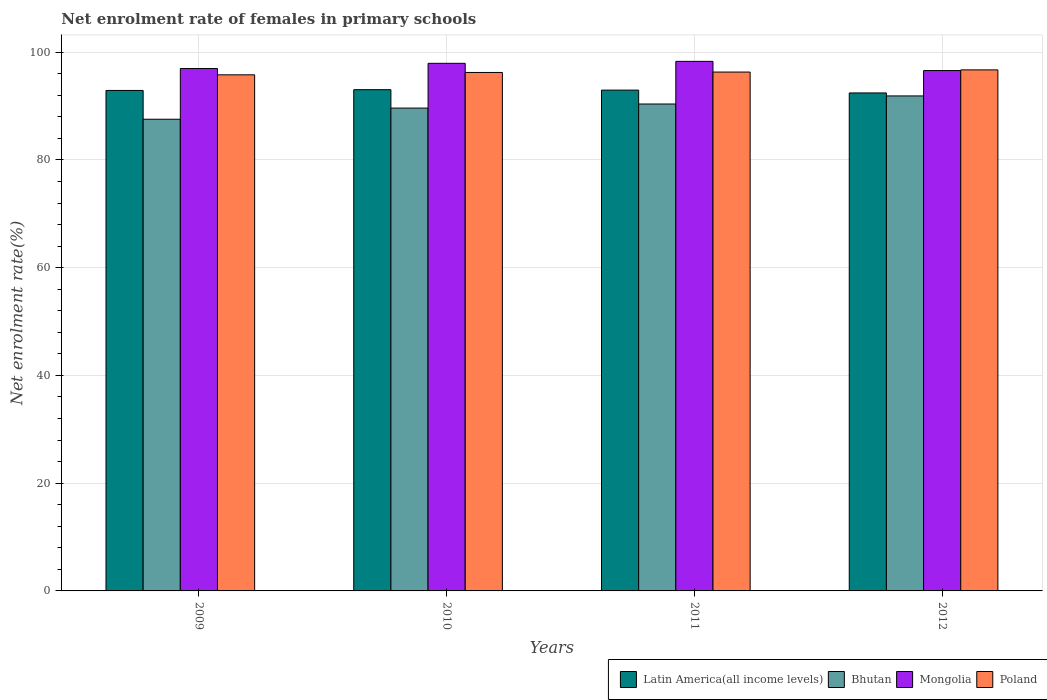How many different coloured bars are there?
Your answer should be very brief. 4. How many groups of bars are there?
Your answer should be compact. 4. Are the number of bars per tick equal to the number of legend labels?
Make the answer very short. Yes. Are the number of bars on each tick of the X-axis equal?
Keep it short and to the point. Yes. How many bars are there on the 2nd tick from the left?
Your answer should be compact. 4. How many bars are there on the 1st tick from the right?
Provide a succinct answer. 4. What is the label of the 2nd group of bars from the left?
Give a very brief answer. 2010. What is the net enrolment rate of females in primary schools in Bhutan in 2012?
Keep it short and to the point. 91.89. Across all years, what is the maximum net enrolment rate of females in primary schools in Mongolia?
Keep it short and to the point. 98.31. Across all years, what is the minimum net enrolment rate of females in primary schools in Bhutan?
Your answer should be very brief. 87.56. In which year was the net enrolment rate of females in primary schools in Latin America(all income levels) minimum?
Your response must be concise. 2012. What is the total net enrolment rate of females in primary schools in Poland in the graph?
Keep it short and to the point. 385.11. What is the difference between the net enrolment rate of females in primary schools in Poland in 2009 and that in 2012?
Make the answer very short. -0.92. What is the difference between the net enrolment rate of females in primary schools in Poland in 2011 and the net enrolment rate of females in primary schools in Mongolia in 2010?
Offer a terse response. -1.62. What is the average net enrolment rate of females in primary schools in Latin America(all income levels) per year?
Your answer should be compact. 92.84. In the year 2010, what is the difference between the net enrolment rate of females in primary schools in Poland and net enrolment rate of females in primary schools in Bhutan?
Make the answer very short. 6.61. In how many years, is the net enrolment rate of females in primary schools in Mongolia greater than 52 %?
Offer a terse response. 4. What is the ratio of the net enrolment rate of females in primary schools in Mongolia in 2009 to that in 2012?
Your response must be concise. 1. Is the net enrolment rate of females in primary schools in Bhutan in 2009 less than that in 2011?
Give a very brief answer. Yes. What is the difference between the highest and the second highest net enrolment rate of females in primary schools in Bhutan?
Make the answer very short. 1.5. What is the difference between the highest and the lowest net enrolment rate of females in primary schools in Bhutan?
Your answer should be very brief. 4.33. In how many years, is the net enrolment rate of females in primary schools in Mongolia greater than the average net enrolment rate of females in primary schools in Mongolia taken over all years?
Your response must be concise. 2. What does the 3rd bar from the left in 2011 represents?
Give a very brief answer. Mongolia. What does the 4th bar from the right in 2009 represents?
Keep it short and to the point. Latin America(all income levels). How many years are there in the graph?
Make the answer very short. 4. What is the difference between two consecutive major ticks on the Y-axis?
Offer a very short reply. 20. Are the values on the major ticks of Y-axis written in scientific E-notation?
Provide a succinct answer. No. Does the graph contain any zero values?
Offer a terse response. No. How many legend labels are there?
Give a very brief answer. 4. How are the legend labels stacked?
Provide a short and direct response. Horizontal. What is the title of the graph?
Your response must be concise. Net enrolment rate of females in primary schools. What is the label or title of the Y-axis?
Your answer should be very brief. Net enrolment rate(%). What is the Net enrolment rate(%) in Latin America(all income levels) in 2009?
Provide a short and direct response. 92.91. What is the Net enrolment rate(%) in Bhutan in 2009?
Give a very brief answer. 87.56. What is the Net enrolment rate(%) of Mongolia in 2009?
Provide a succinct answer. 96.97. What is the Net enrolment rate(%) in Poland in 2009?
Your response must be concise. 95.81. What is the Net enrolment rate(%) in Latin America(all income levels) in 2010?
Your answer should be compact. 93.05. What is the Net enrolment rate(%) of Bhutan in 2010?
Provide a short and direct response. 89.63. What is the Net enrolment rate(%) of Mongolia in 2010?
Your answer should be very brief. 97.94. What is the Net enrolment rate(%) of Poland in 2010?
Provide a succinct answer. 96.25. What is the Net enrolment rate(%) in Latin America(all income levels) in 2011?
Offer a very short reply. 92.97. What is the Net enrolment rate(%) of Bhutan in 2011?
Ensure brevity in your answer.  90.39. What is the Net enrolment rate(%) of Mongolia in 2011?
Offer a terse response. 98.31. What is the Net enrolment rate(%) of Poland in 2011?
Offer a terse response. 96.32. What is the Net enrolment rate(%) of Latin America(all income levels) in 2012?
Your response must be concise. 92.45. What is the Net enrolment rate(%) of Bhutan in 2012?
Provide a succinct answer. 91.89. What is the Net enrolment rate(%) of Mongolia in 2012?
Provide a succinct answer. 96.6. What is the Net enrolment rate(%) of Poland in 2012?
Offer a very short reply. 96.73. Across all years, what is the maximum Net enrolment rate(%) of Latin America(all income levels)?
Keep it short and to the point. 93.05. Across all years, what is the maximum Net enrolment rate(%) of Bhutan?
Ensure brevity in your answer.  91.89. Across all years, what is the maximum Net enrolment rate(%) of Mongolia?
Your response must be concise. 98.31. Across all years, what is the maximum Net enrolment rate(%) of Poland?
Your answer should be very brief. 96.73. Across all years, what is the minimum Net enrolment rate(%) of Latin America(all income levels)?
Provide a short and direct response. 92.45. Across all years, what is the minimum Net enrolment rate(%) in Bhutan?
Make the answer very short. 87.56. Across all years, what is the minimum Net enrolment rate(%) in Mongolia?
Your answer should be compact. 96.6. Across all years, what is the minimum Net enrolment rate(%) in Poland?
Offer a terse response. 95.81. What is the total Net enrolment rate(%) in Latin America(all income levels) in the graph?
Keep it short and to the point. 371.38. What is the total Net enrolment rate(%) in Bhutan in the graph?
Offer a very short reply. 359.48. What is the total Net enrolment rate(%) of Mongolia in the graph?
Your answer should be very brief. 389.83. What is the total Net enrolment rate(%) of Poland in the graph?
Make the answer very short. 385.11. What is the difference between the Net enrolment rate(%) of Latin America(all income levels) in 2009 and that in 2010?
Make the answer very short. -0.14. What is the difference between the Net enrolment rate(%) of Bhutan in 2009 and that in 2010?
Ensure brevity in your answer.  -2.07. What is the difference between the Net enrolment rate(%) in Mongolia in 2009 and that in 2010?
Provide a succinct answer. -0.97. What is the difference between the Net enrolment rate(%) in Poland in 2009 and that in 2010?
Keep it short and to the point. -0.44. What is the difference between the Net enrolment rate(%) in Latin America(all income levels) in 2009 and that in 2011?
Your answer should be very brief. -0.06. What is the difference between the Net enrolment rate(%) of Bhutan in 2009 and that in 2011?
Give a very brief answer. -2.83. What is the difference between the Net enrolment rate(%) in Mongolia in 2009 and that in 2011?
Your response must be concise. -1.33. What is the difference between the Net enrolment rate(%) in Poland in 2009 and that in 2011?
Offer a terse response. -0.52. What is the difference between the Net enrolment rate(%) of Latin America(all income levels) in 2009 and that in 2012?
Provide a short and direct response. 0.46. What is the difference between the Net enrolment rate(%) of Bhutan in 2009 and that in 2012?
Ensure brevity in your answer.  -4.33. What is the difference between the Net enrolment rate(%) in Mongolia in 2009 and that in 2012?
Your answer should be compact. 0.37. What is the difference between the Net enrolment rate(%) of Poland in 2009 and that in 2012?
Provide a succinct answer. -0.92. What is the difference between the Net enrolment rate(%) in Latin America(all income levels) in 2010 and that in 2011?
Your answer should be very brief. 0.08. What is the difference between the Net enrolment rate(%) of Bhutan in 2010 and that in 2011?
Your answer should be very brief. -0.76. What is the difference between the Net enrolment rate(%) of Mongolia in 2010 and that in 2011?
Your answer should be compact. -0.37. What is the difference between the Net enrolment rate(%) in Poland in 2010 and that in 2011?
Make the answer very short. -0.08. What is the difference between the Net enrolment rate(%) in Latin America(all income levels) in 2010 and that in 2012?
Offer a very short reply. 0.61. What is the difference between the Net enrolment rate(%) in Bhutan in 2010 and that in 2012?
Ensure brevity in your answer.  -2.26. What is the difference between the Net enrolment rate(%) in Mongolia in 2010 and that in 2012?
Provide a succinct answer. 1.34. What is the difference between the Net enrolment rate(%) of Poland in 2010 and that in 2012?
Ensure brevity in your answer.  -0.48. What is the difference between the Net enrolment rate(%) in Latin America(all income levels) in 2011 and that in 2012?
Your answer should be compact. 0.52. What is the difference between the Net enrolment rate(%) in Bhutan in 2011 and that in 2012?
Make the answer very short. -1.5. What is the difference between the Net enrolment rate(%) in Mongolia in 2011 and that in 2012?
Ensure brevity in your answer.  1.71. What is the difference between the Net enrolment rate(%) in Poland in 2011 and that in 2012?
Your answer should be very brief. -0.4. What is the difference between the Net enrolment rate(%) in Latin America(all income levels) in 2009 and the Net enrolment rate(%) in Bhutan in 2010?
Provide a succinct answer. 3.28. What is the difference between the Net enrolment rate(%) in Latin America(all income levels) in 2009 and the Net enrolment rate(%) in Mongolia in 2010?
Give a very brief answer. -5.04. What is the difference between the Net enrolment rate(%) in Latin America(all income levels) in 2009 and the Net enrolment rate(%) in Poland in 2010?
Give a very brief answer. -3.34. What is the difference between the Net enrolment rate(%) of Bhutan in 2009 and the Net enrolment rate(%) of Mongolia in 2010?
Offer a very short reply. -10.38. What is the difference between the Net enrolment rate(%) of Bhutan in 2009 and the Net enrolment rate(%) of Poland in 2010?
Your answer should be very brief. -8.69. What is the difference between the Net enrolment rate(%) of Mongolia in 2009 and the Net enrolment rate(%) of Poland in 2010?
Your answer should be very brief. 0.73. What is the difference between the Net enrolment rate(%) in Latin America(all income levels) in 2009 and the Net enrolment rate(%) in Bhutan in 2011?
Offer a very short reply. 2.52. What is the difference between the Net enrolment rate(%) of Latin America(all income levels) in 2009 and the Net enrolment rate(%) of Mongolia in 2011?
Keep it short and to the point. -5.4. What is the difference between the Net enrolment rate(%) in Latin America(all income levels) in 2009 and the Net enrolment rate(%) in Poland in 2011?
Offer a very short reply. -3.42. What is the difference between the Net enrolment rate(%) of Bhutan in 2009 and the Net enrolment rate(%) of Mongolia in 2011?
Ensure brevity in your answer.  -10.75. What is the difference between the Net enrolment rate(%) in Bhutan in 2009 and the Net enrolment rate(%) in Poland in 2011?
Offer a very short reply. -8.76. What is the difference between the Net enrolment rate(%) of Mongolia in 2009 and the Net enrolment rate(%) of Poland in 2011?
Provide a short and direct response. 0.65. What is the difference between the Net enrolment rate(%) of Latin America(all income levels) in 2009 and the Net enrolment rate(%) of Bhutan in 2012?
Ensure brevity in your answer.  1.02. What is the difference between the Net enrolment rate(%) in Latin America(all income levels) in 2009 and the Net enrolment rate(%) in Mongolia in 2012?
Offer a terse response. -3.69. What is the difference between the Net enrolment rate(%) in Latin America(all income levels) in 2009 and the Net enrolment rate(%) in Poland in 2012?
Ensure brevity in your answer.  -3.82. What is the difference between the Net enrolment rate(%) in Bhutan in 2009 and the Net enrolment rate(%) in Mongolia in 2012?
Provide a succinct answer. -9.04. What is the difference between the Net enrolment rate(%) of Bhutan in 2009 and the Net enrolment rate(%) of Poland in 2012?
Your answer should be compact. -9.17. What is the difference between the Net enrolment rate(%) in Mongolia in 2009 and the Net enrolment rate(%) in Poland in 2012?
Make the answer very short. 0.25. What is the difference between the Net enrolment rate(%) in Latin America(all income levels) in 2010 and the Net enrolment rate(%) in Bhutan in 2011?
Ensure brevity in your answer.  2.66. What is the difference between the Net enrolment rate(%) in Latin America(all income levels) in 2010 and the Net enrolment rate(%) in Mongolia in 2011?
Ensure brevity in your answer.  -5.26. What is the difference between the Net enrolment rate(%) in Latin America(all income levels) in 2010 and the Net enrolment rate(%) in Poland in 2011?
Provide a short and direct response. -3.27. What is the difference between the Net enrolment rate(%) of Bhutan in 2010 and the Net enrolment rate(%) of Mongolia in 2011?
Keep it short and to the point. -8.68. What is the difference between the Net enrolment rate(%) of Bhutan in 2010 and the Net enrolment rate(%) of Poland in 2011?
Offer a terse response. -6.69. What is the difference between the Net enrolment rate(%) in Mongolia in 2010 and the Net enrolment rate(%) in Poland in 2011?
Keep it short and to the point. 1.62. What is the difference between the Net enrolment rate(%) in Latin America(all income levels) in 2010 and the Net enrolment rate(%) in Bhutan in 2012?
Ensure brevity in your answer.  1.16. What is the difference between the Net enrolment rate(%) of Latin America(all income levels) in 2010 and the Net enrolment rate(%) of Mongolia in 2012?
Provide a succinct answer. -3.55. What is the difference between the Net enrolment rate(%) of Latin America(all income levels) in 2010 and the Net enrolment rate(%) of Poland in 2012?
Keep it short and to the point. -3.68. What is the difference between the Net enrolment rate(%) in Bhutan in 2010 and the Net enrolment rate(%) in Mongolia in 2012?
Give a very brief answer. -6.97. What is the difference between the Net enrolment rate(%) of Bhutan in 2010 and the Net enrolment rate(%) of Poland in 2012?
Provide a short and direct response. -7.09. What is the difference between the Net enrolment rate(%) in Mongolia in 2010 and the Net enrolment rate(%) in Poland in 2012?
Ensure brevity in your answer.  1.22. What is the difference between the Net enrolment rate(%) in Latin America(all income levels) in 2011 and the Net enrolment rate(%) in Bhutan in 2012?
Offer a very short reply. 1.08. What is the difference between the Net enrolment rate(%) in Latin America(all income levels) in 2011 and the Net enrolment rate(%) in Mongolia in 2012?
Provide a short and direct response. -3.63. What is the difference between the Net enrolment rate(%) of Latin America(all income levels) in 2011 and the Net enrolment rate(%) of Poland in 2012?
Make the answer very short. -3.76. What is the difference between the Net enrolment rate(%) of Bhutan in 2011 and the Net enrolment rate(%) of Mongolia in 2012?
Your answer should be very brief. -6.21. What is the difference between the Net enrolment rate(%) of Bhutan in 2011 and the Net enrolment rate(%) of Poland in 2012?
Your answer should be compact. -6.34. What is the difference between the Net enrolment rate(%) in Mongolia in 2011 and the Net enrolment rate(%) in Poland in 2012?
Your answer should be compact. 1.58. What is the average Net enrolment rate(%) of Latin America(all income levels) per year?
Offer a terse response. 92.84. What is the average Net enrolment rate(%) of Bhutan per year?
Offer a terse response. 89.87. What is the average Net enrolment rate(%) in Mongolia per year?
Offer a terse response. 97.46. What is the average Net enrolment rate(%) in Poland per year?
Your answer should be very brief. 96.28. In the year 2009, what is the difference between the Net enrolment rate(%) in Latin America(all income levels) and Net enrolment rate(%) in Bhutan?
Give a very brief answer. 5.35. In the year 2009, what is the difference between the Net enrolment rate(%) in Latin America(all income levels) and Net enrolment rate(%) in Mongolia?
Offer a very short reply. -4.07. In the year 2009, what is the difference between the Net enrolment rate(%) in Latin America(all income levels) and Net enrolment rate(%) in Poland?
Ensure brevity in your answer.  -2.9. In the year 2009, what is the difference between the Net enrolment rate(%) of Bhutan and Net enrolment rate(%) of Mongolia?
Give a very brief answer. -9.41. In the year 2009, what is the difference between the Net enrolment rate(%) of Bhutan and Net enrolment rate(%) of Poland?
Ensure brevity in your answer.  -8.25. In the year 2009, what is the difference between the Net enrolment rate(%) in Mongolia and Net enrolment rate(%) in Poland?
Make the answer very short. 1.17. In the year 2010, what is the difference between the Net enrolment rate(%) in Latin America(all income levels) and Net enrolment rate(%) in Bhutan?
Make the answer very short. 3.42. In the year 2010, what is the difference between the Net enrolment rate(%) of Latin America(all income levels) and Net enrolment rate(%) of Mongolia?
Provide a succinct answer. -4.89. In the year 2010, what is the difference between the Net enrolment rate(%) of Latin America(all income levels) and Net enrolment rate(%) of Poland?
Your response must be concise. -3.2. In the year 2010, what is the difference between the Net enrolment rate(%) of Bhutan and Net enrolment rate(%) of Mongolia?
Your response must be concise. -8.31. In the year 2010, what is the difference between the Net enrolment rate(%) of Bhutan and Net enrolment rate(%) of Poland?
Offer a terse response. -6.61. In the year 2010, what is the difference between the Net enrolment rate(%) in Mongolia and Net enrolment rate(%) in Poland?
Keep it short and to the point. 1.7. In the year 2011, what is the difference between the Net enrolment rate(%) in Latin America(all income levels) and Net enrolment rate(%) in Bhutan?
Offer a very short reply. 2.58. In the year 2011, what is the difference between the Net enrolment rate(%) of Latin America(all income levels) and Net enrolment rate(%) of Mongolia?
Your response must be concise. -5.34. In the year 2011, what is the difference between the Net enrolment rate(%) of Latin America(all income levels) and Net enrolment rate(%) of Poland?
Your answer should be compact. -3.35. In the year 2011, what is the difference between the Net enrolment rate(%) in Bhutan and Net enrolment rate(%) in Mongolia?
Provide a succinct answer. -7.92. In the year 2011, what is the difference between the Net enrolment rate(%) in Bhutan and Net enrolment rate(%) in Poland?
Keep it short and to the point. -5.93. In the year 2011, what is the difference between the Net enrolment rate(%) of Mongolia and Net enrolment rate(%) of Poland?
Provide a short and direct response. 1.99. In the year 2012, what is the difference between the Net enrolment rate(%) in Latin America(all income levels) and Net enrolment rate(%) in Bhutan?
Your answer should be very brief. 0.56. In the year 2012, what is the difference between the Net enrolment rate(%) in Latin America(all income levels) and Net enrolment rate(%) in Mongolia?
Offer a very short reply. -4.16. In the year 2012, what is the difference between the Net enrolment rate(%) of Latin America(all income levels) and Net enrolment rate(%) of Poland?
Your answer should be very brief. -4.28. In the year 2012, what is the difference between the Net enrolment rate(%) in Bhutan and Net enrolment rate(%) in Mongolia?
Ensure brevity in your answer.  -4.71. In the year 2012, what is the difference between the Net enrolment rate(%) in Bhutan and Net enrolment rate(%) in Poland?
Your answer should be very brief. -4.84. In the year 2012, what is the difference between the Net enrolment rate(%) in Mongolia and Net enrolment rate(%) in Poland?
Offer a terse response. -0.13. What is the ratio of the Net enrolment rate(%) of Bhutan in 2009 to that in 2010?
Give a very brief answer. 0.98. What is the ratio of the Net enrolment rate(%) of Poland in 2009 to that in 2010?
Make the answer very short. 1. What is the ratio of the Net enrolment rate(%) in Bhutan in 2009 to that in 2011?
Ensure brevity in your answer.  0.97. What is the ratio of the Net enrolment rate(%) in Mongolia in 2009 to that in 2011?
Your answer should be very brief. 0.99. What is the ratio of the Net enrolment rate(%) in Bhutan in 2009 to that in 2012?
Your answer should be compact. 0.95. What is the ratio of the Net enrolment rate(%) of Latin America(all income levels) in 2010 to that in 2011?
Ensure brevity in your answer.  1. What is the ratio of the Net enrolment rate(%) in Mongolia in 2010 to that in 2011?
Your answer should be very brief. 1. What is the ratio of the Net enrolment rate(%) in Latin America(all income levels) in 2010 to that in 2012?
Ensure brevity in your answer.  1.01. What is the ratio of the Net enrolment rate(%) of Bhutan in 2010 to that in 2012?
Your answer should be compact. 0.98. What is the ratio of the Net enrolment rate(%) in Mongolia in 2010 to that in 2012?
Your answer should be compact. 1.01. What is the ratio of the Net enrolment rate(%) in Poland in 2010 to that in 2012?
Ensure brevity in your answer.  0.99. What is the ratio of the Net enrolment rate(%) of Latin America(all income levels) in 2011 to that in 2012?
Your answer should be compact. 1.01. What is the ratio of the Net enrolment rate(%) of Bhutan in 2011 to that in 2012?
Keep it short and to the point. 0.98. What is the ratio of the Net enrolment rate(%) in Mongolia in 2011 to that in 2012?
Your answer should be very brief. 1.02. What is the ratio of the Net enrolment rate(%) of Poland in 2011 to that in 2012?
Offer a terse response. 1. What is the difference between the highest and the second highest Net enrolment rate(%) of Latin America(all income levels)?
Provide a succinct answer. 0.08. What is the difference between the highest and the second highest Net enrolment rate(%) of Bhutan?
Provide a succinct answer. 1.5. What is the difference between the highest and the second highest Net enrolment rate(%) of Mongolia?
Ensure brevity in your answer.  0.37. What is the difference between the highest and the second highest Net enrolment rate(%) of Poland?
Offer a very short reply. 0.4. What is the difference between the highest and the lowest Net enrolment rate(%) in Latin America(all income levels)?
Your answer should be very brief. 0.61. What is the difference between the highest and the lowest Net enrolment rate(%) of Bhutan?
Keep it short and to the point. 4.33. What is the difference between the highest and the lowest Net enrolment rate(%) of Mongolia?
Make the answer very short. 1.71. What is the difference between the highest and the lowest Net enrolment rate(%) of Poland?
Your answer should be compact. 0.92. 